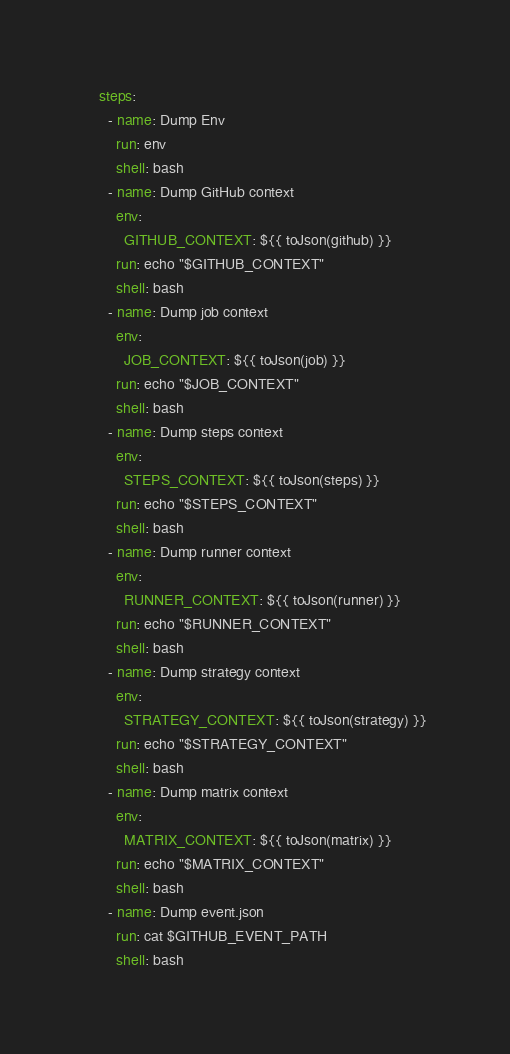Convert code to text. <code><loc_0><loc_0><loc_500><loc_500><_YAML_>
    steps:
      - name: Dump Env
        run: env
        shell: bash
      - name: Dump GitHub context
        env:
          GITHUB_CONTEXT: ${{ toJson(github) }}
        run: echo "$GITHUB_CONTEXT"
        shell: bash
      - name: Dump job context
        env:
          JOB_CONTEXT: ${{ toJson(job) }}
        run: echo "$JOB_CONTEXT"
        shell: bash
      - name: Dump steps context
        env:
          STEPS_CONTEXT: ${{ toJson(steps) }}
        run: echo "$STEPS_CONTEXT"
        shell: bash
      - name: Dump runner context
        env:
          RUNNER_CONTEXT: ${{ toJson(runner) }}
        run: echo "$RUNNER_CONTEXT"
        shell: bash
      - name: Dump strategy context
        env:
          STRATEGY_CONTEXT: ${{ toJson(strategy) }}
        run: echo "$STRATEGY_CONTEXT"
        shell: bash
      - name: Dump matrix context
        env:
          MATRIX_CONTEXT: ${{ toJson(matrix) }}
        run: echo "$MATRIX_CONTEXT"
        shell: bash
      - name: Dump event.json
        run: cat $GITHUB_EVENT_PATH
        shell: bash
</code> 